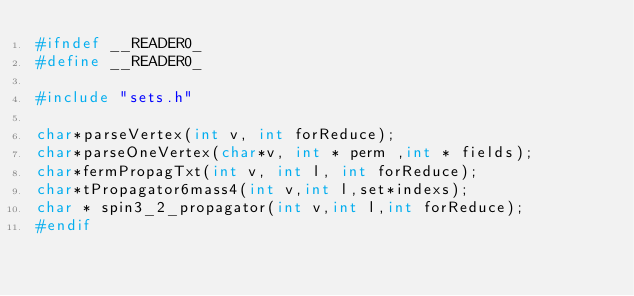Convert code to text. <code><loc_0><loc_0><loc_500><loc_500><_C_>#ifndef __READER0_
#define __READER0_

#include "sets.h"

char*parseVertex(int v, int forReduce);
char*parseOneVertex(char*v, int * perm ,int * fields);
char*fermPropagTxt(int v, int l, int forReduce);
char*tPropagator6mass4(int v,int l,set*indexs);
char * spin3_2_propagator(int v,int l,int forReduce);
#endif
</code> 